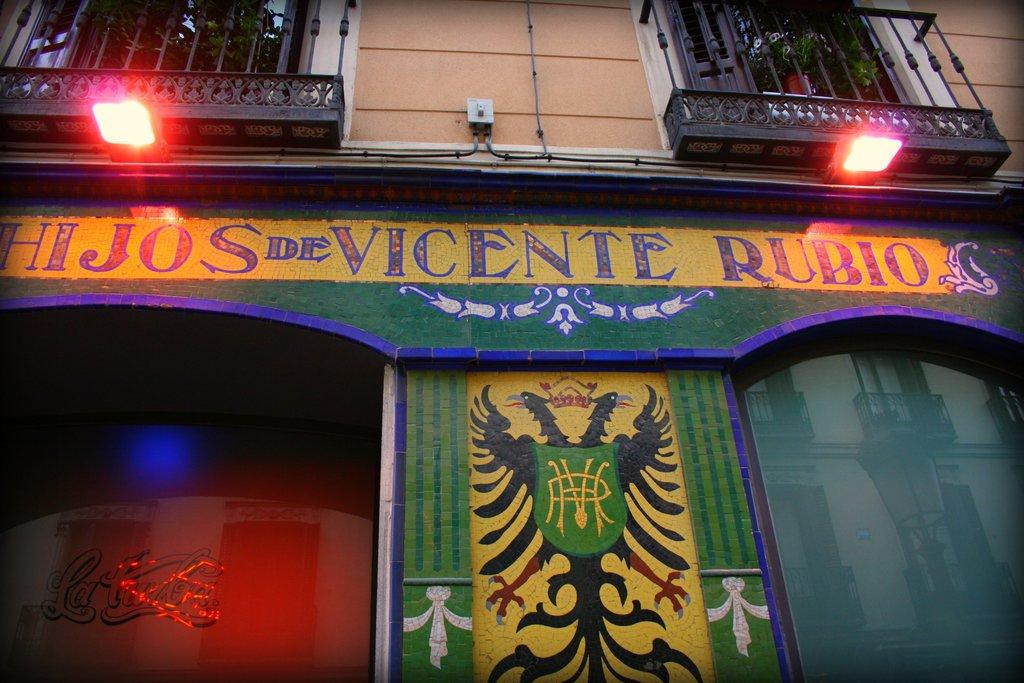What type of structure is visible in the image? There is a building in the image. What can be seen at the top of the building? There are two lights and railings at the top of the building. What is present in the middle of the image? There is some text in the middle of the image. What type of activity or behavior is taking place with the bikes in the image? There are no bikes present in the image, so no activity or behavior involving bikes can be observed. 